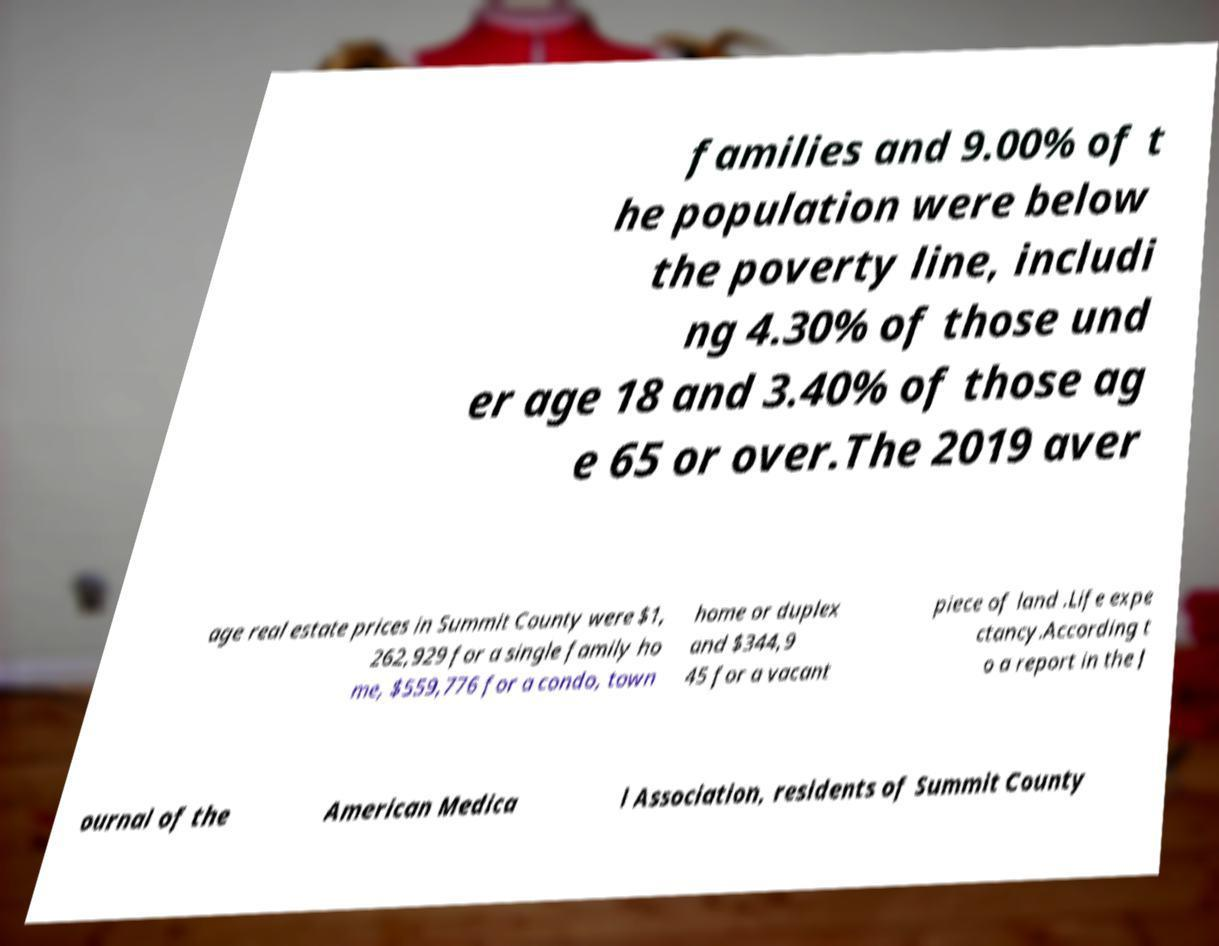Please read and relay the text visible in this image. What does it say? families and 9.00% of t he population were below the poverty line, includi ng 4.30% of those und er age 18 and 3.40% of those ag e 65 or over.The 2019 aver age real estate prices in Summit County were $1, 262,929 for a single family ho me, $559,776 for a condo, town home or duplex and $344,9 45 for a vacant piece of land .Life expe ctancy.According t o a report in the J ournal of the American Medica l Association, residents of Summit County 